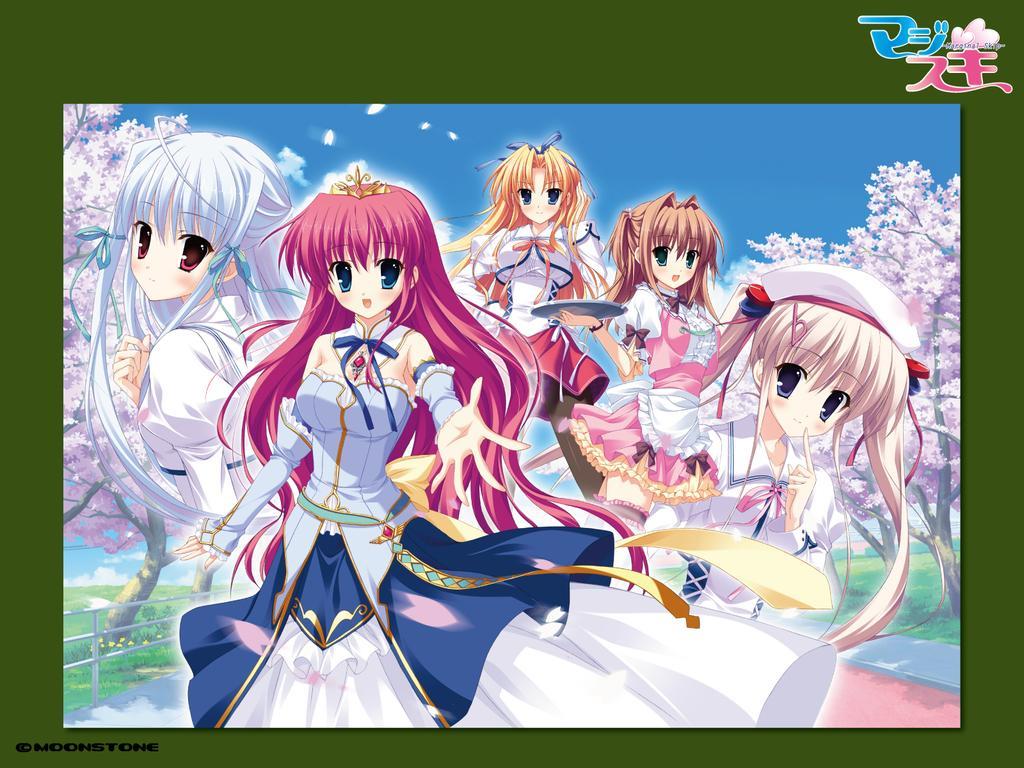Please provide a concise description of this image. This is completely an animated picture. On the background we can see trees and this picture is mainly highlighted with a animated cartoons. 